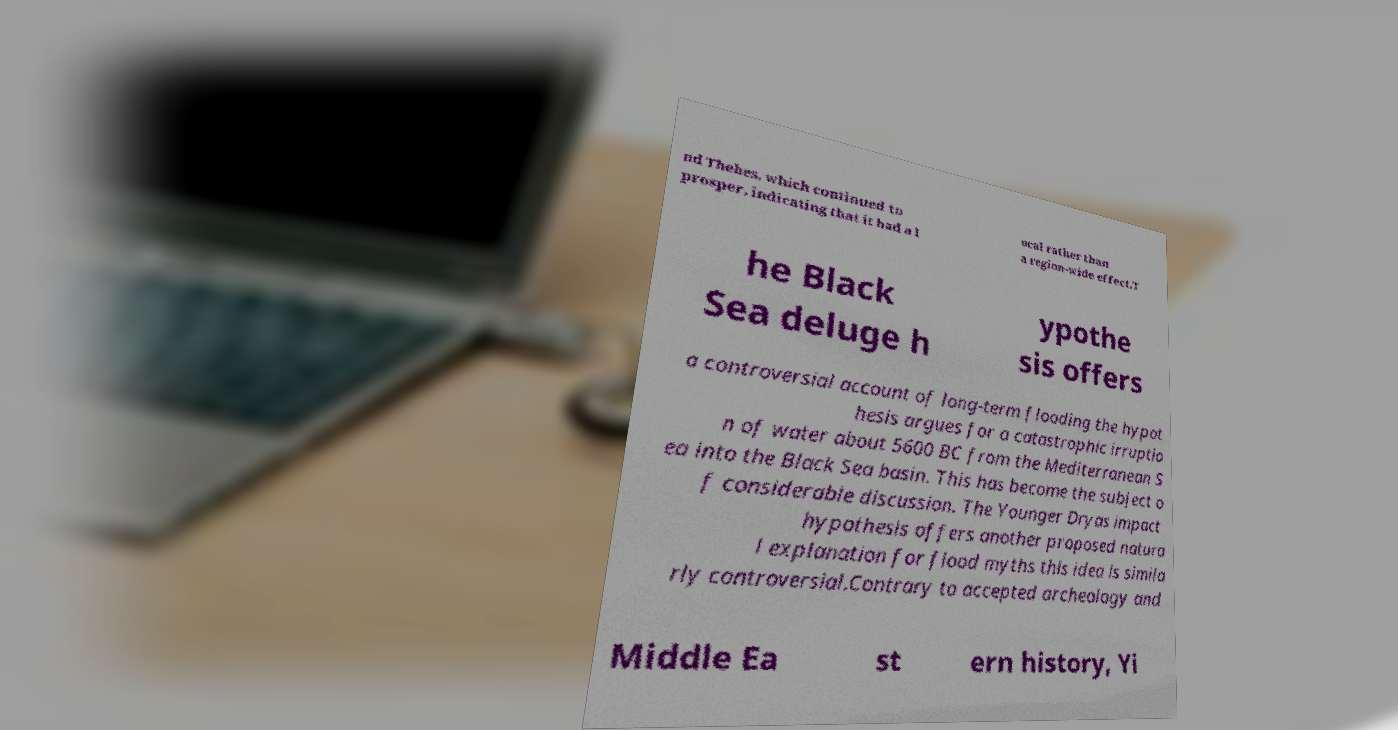Can you accurately transcribe the text from the provided image for me? nd Thebes, which continued to prosper, indicating that it had a l ocal rather than a region-wide effect.T he Black Sea deluge h ypothe sis offers a controversial account of long-term flooding the hypot hesis argues for a catastrophic irruptio n of water about 5600 BC from the Mediterranean S ea into the Black Sea basin. This has become the subject o f considerable discussion. The Younger Dryas impact hypothesis offers another proposed natura l explanation for flood myths this idea is simila rly controversial.Contrary to accepted archeology and Middle Ea st ern history, Yi 